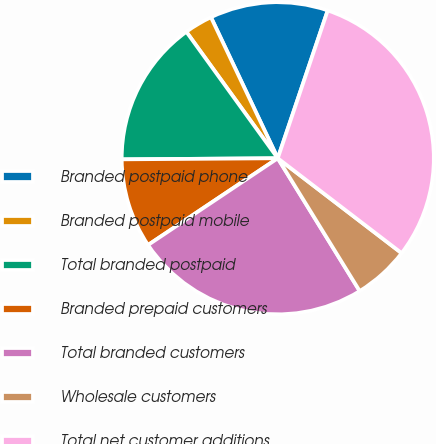Convert chart. <chart><loc_0><loc_0><loc_500><loc_500><pie_chart><fcel>Branded postpaid phone<fcel>Branded postpaid mobile<fcel>Total branded postpaid<fcel>Branded prepaid customers<fcel>Total branded customers<fcel>Wholesale customers<fcel>Total net customer additions<nl><fcel>12.23%<fcel>2.92%<fcel>15.15%<fcel>9.27%<fcel>24.42%<fcel>5.8%<fcel>30.22%<nl></chart> 